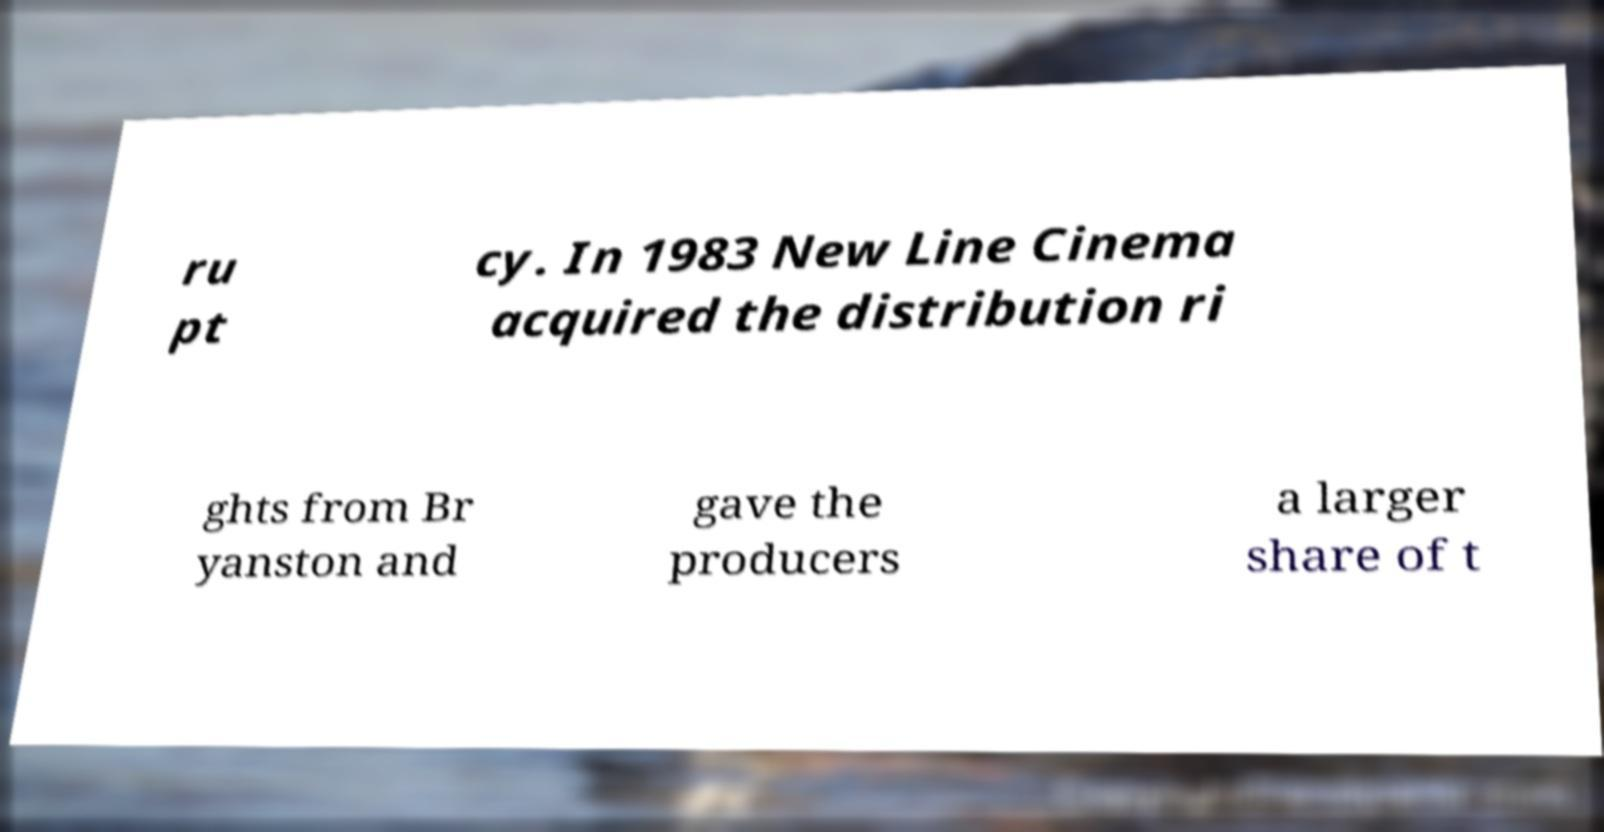What messages or text are displayed in this image? I need them in a readable, typed format. ru pt cy. In 1983 New Line Cinema acquired the distribution ri ghts from Br yanston and gave the producers a larger share of t 